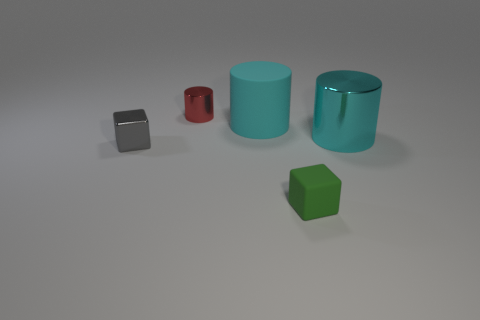Add 1 small gray shiny blocks. How many objects exist? 6 Subtract all cylinders. How many objects are left? 2 Add 4 big cyan matte cylinders. How many big cyan matte cylinders exist? 5 Subtract 0 blue balls. How many objects are left? 5 Subtract all red metal things. Subtract all small gray cubes. How many objects are left? 3 Add 3 cyan cylinders. How many cyan cylinders are left? 5 